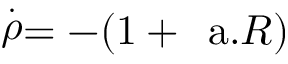Convert formula to latex. <formula><loc_0><loc_0><loc_500><loc_500>\stackrel { . } { \rho } = - ( 1 + a . R )</formula> 